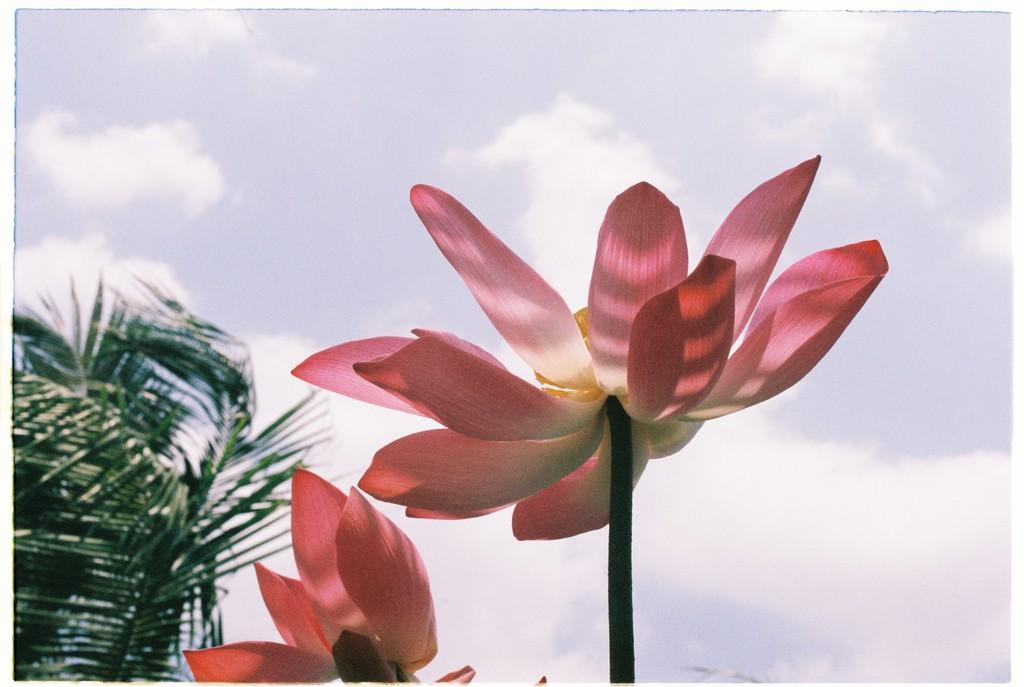What can be seen in the sky in the image? The sky is visible in the image, and there are clouds present. What type of vegetation is in the image? There is a tree in the image. How many flowers with stems can be seen in the image? There are two flowers with stems in the image. What type of food is being stored in the drawer in the image? There is no drawer present in the image, so it is not possible to determine what type of food might be stored in it. 